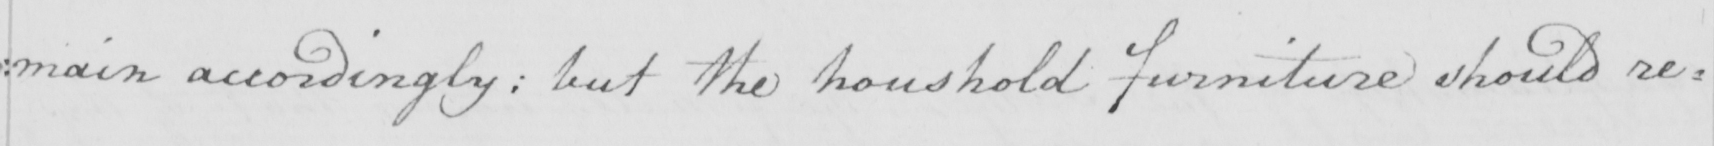What text is written in this handwritten line? : main accordingly ; but the household furniture should re= 